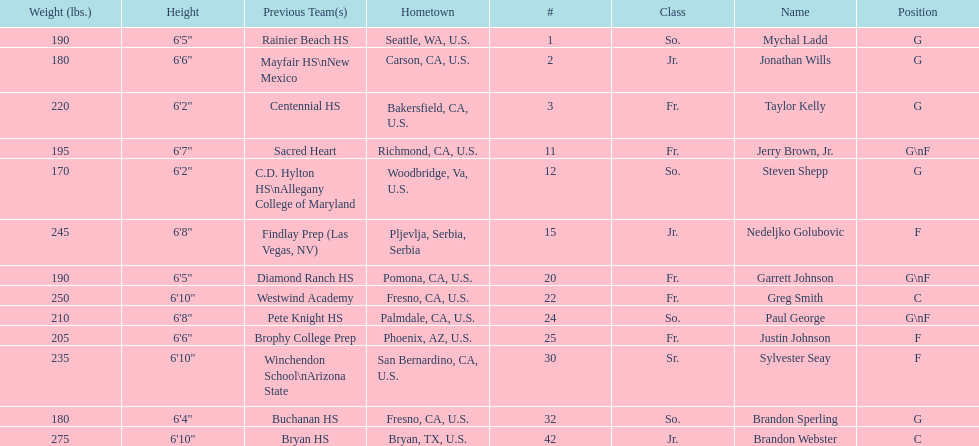Who weighs the most on the team? Brandon Webster. 